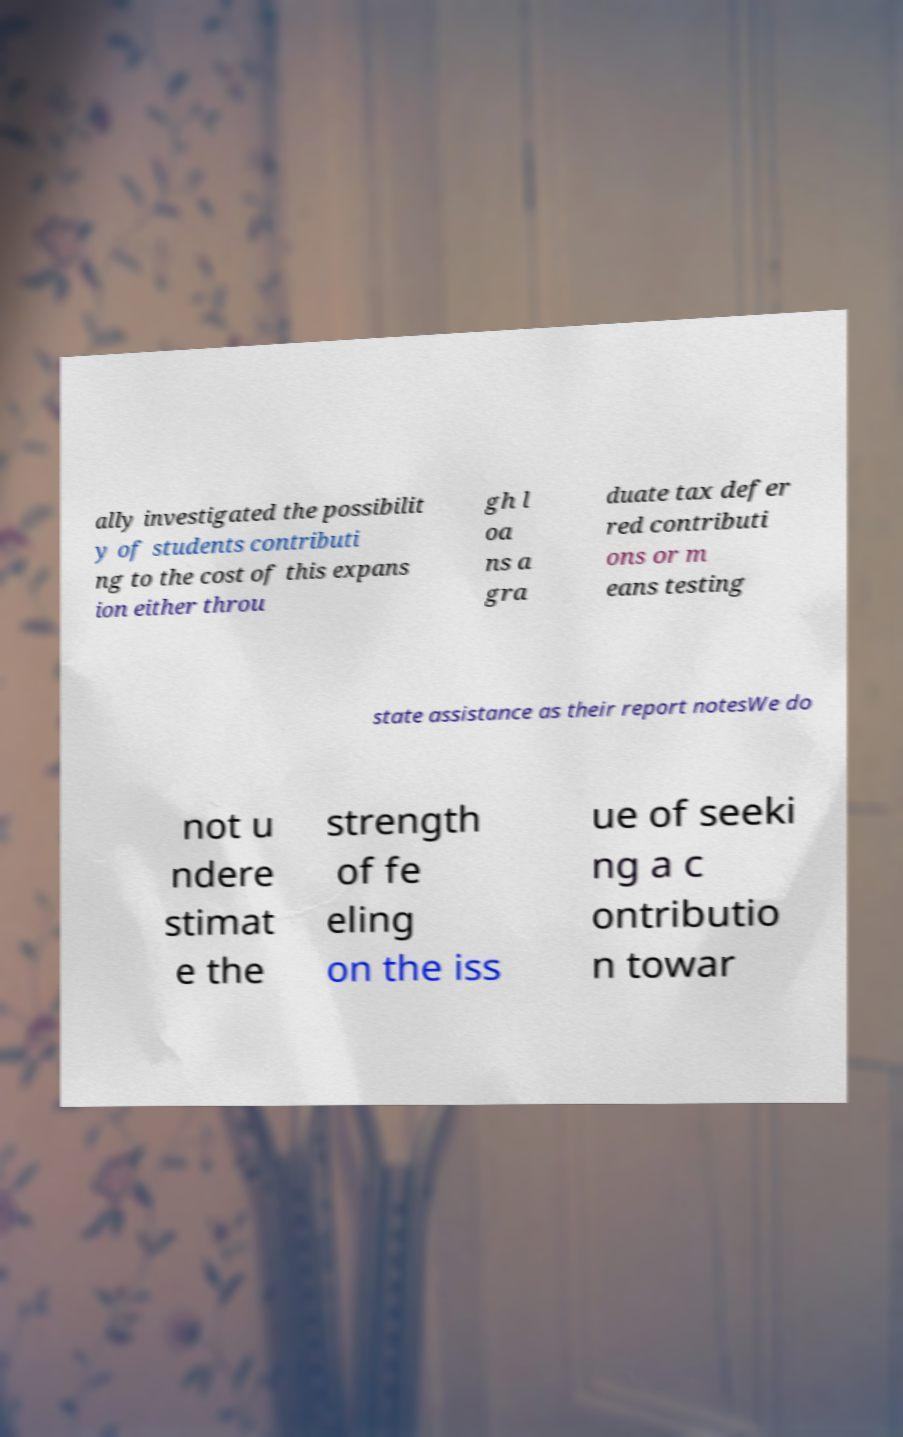I need the written content from this picture converted into text. Can you do that? ally investigated the possibilit y of students contributi ng to the cost of this expans ion either throu gh l oa ns a gra duate tax defer red contributi ons or m eans testing state assistance as their report notesWe do not u ndere stimat e the strength of fe eling on the iss ue of seeki ng a c ontributio n towar 